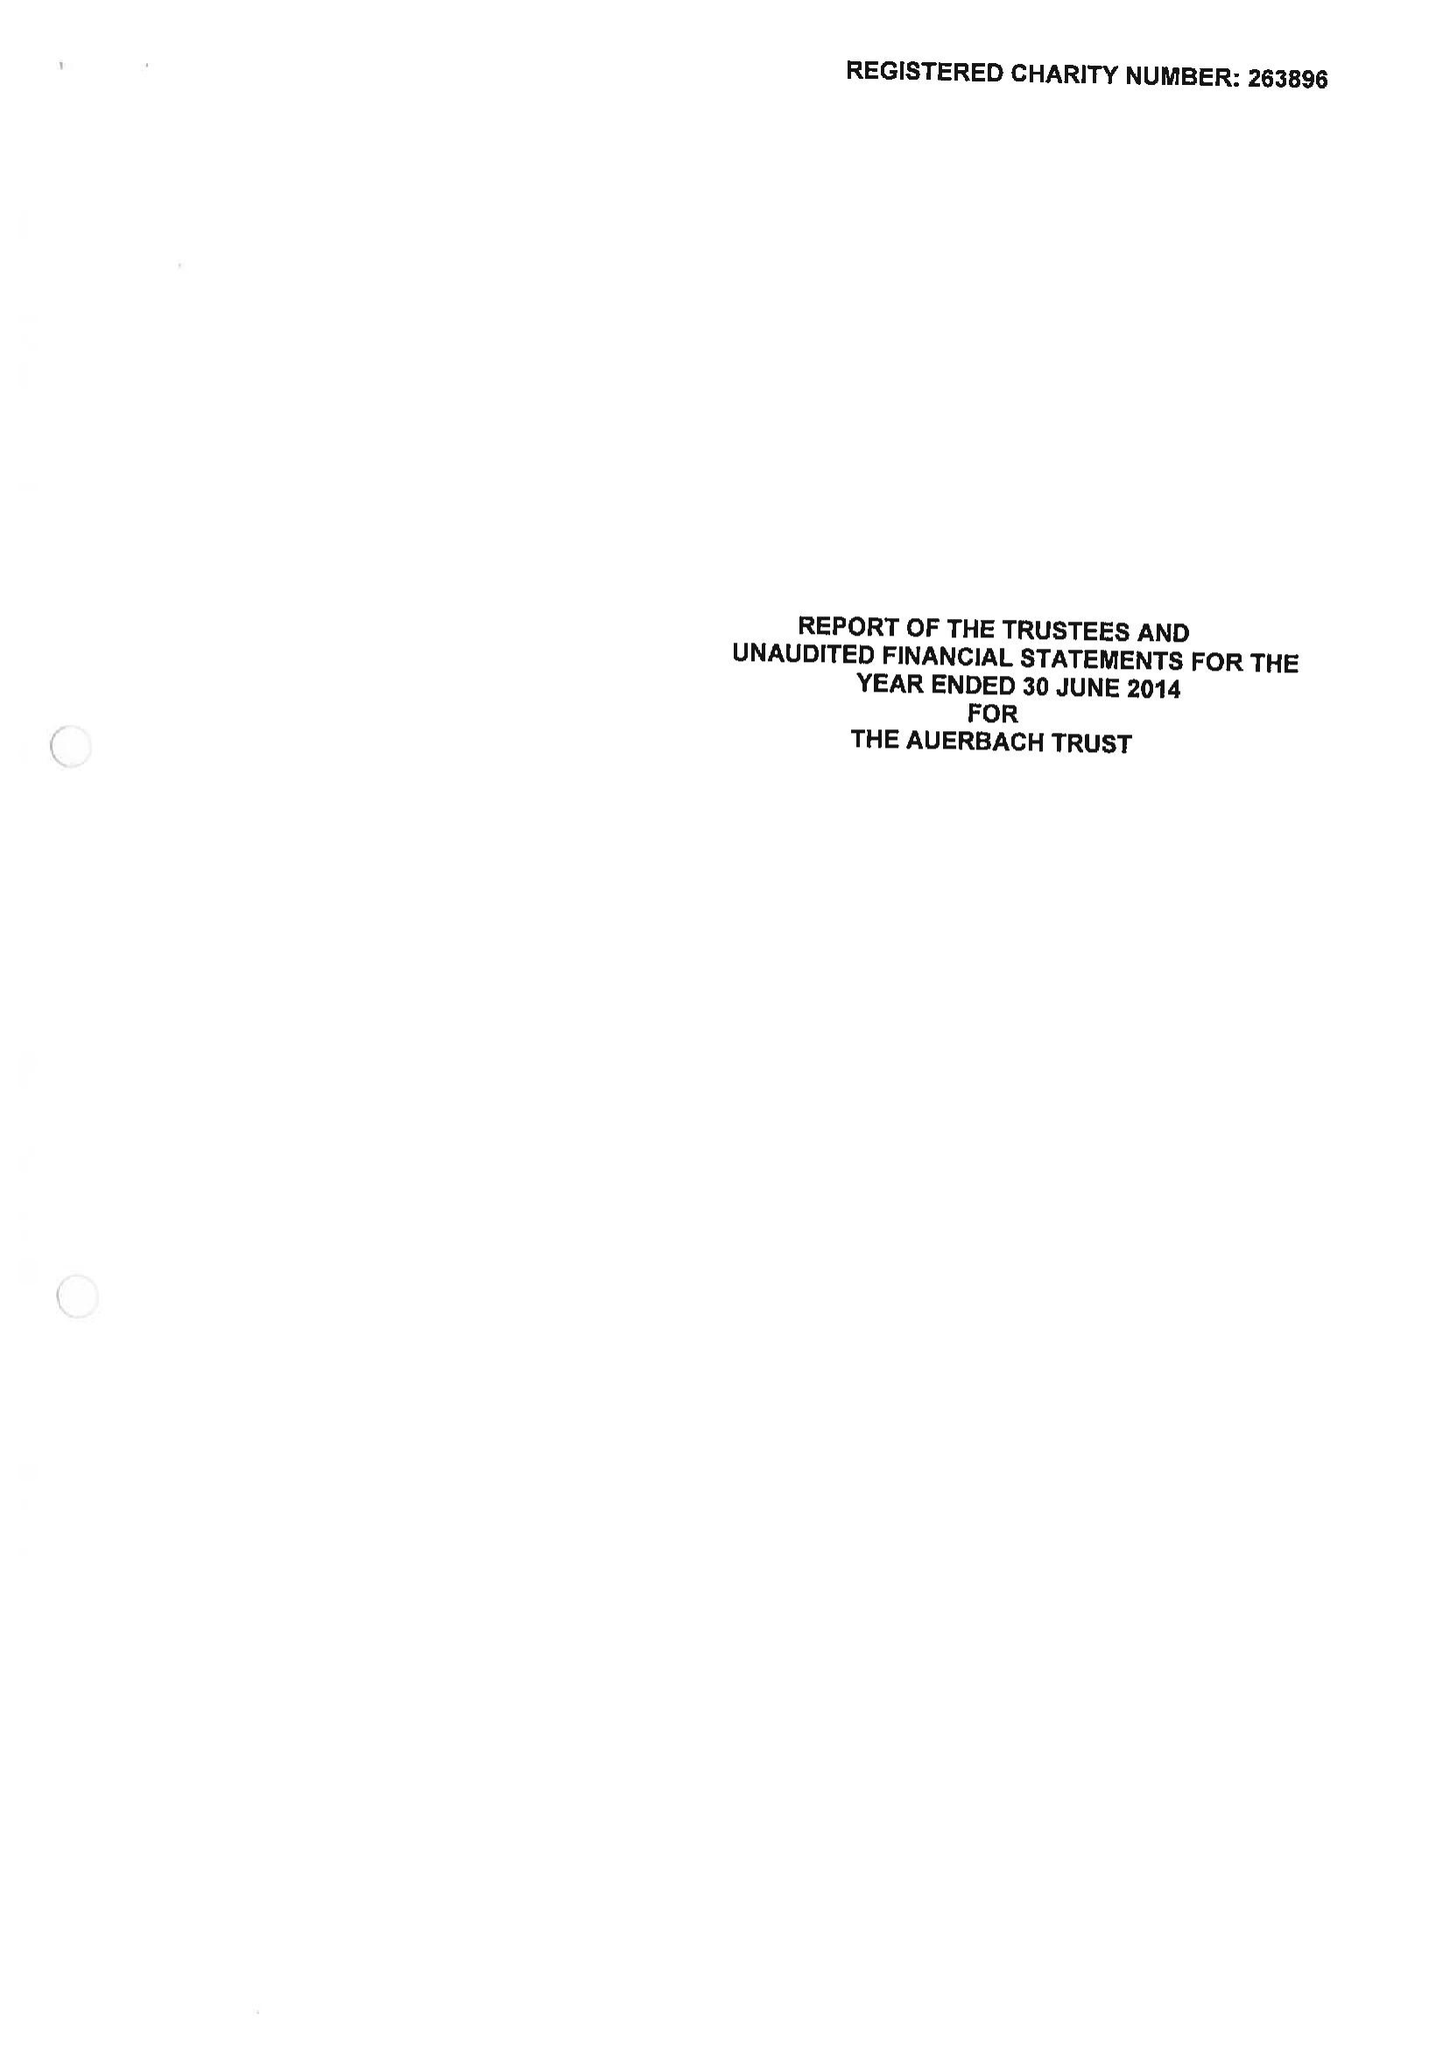What is the value for the income_annually_in_british_pounds?
Answer the question using a single word or phrase. 47615.00 